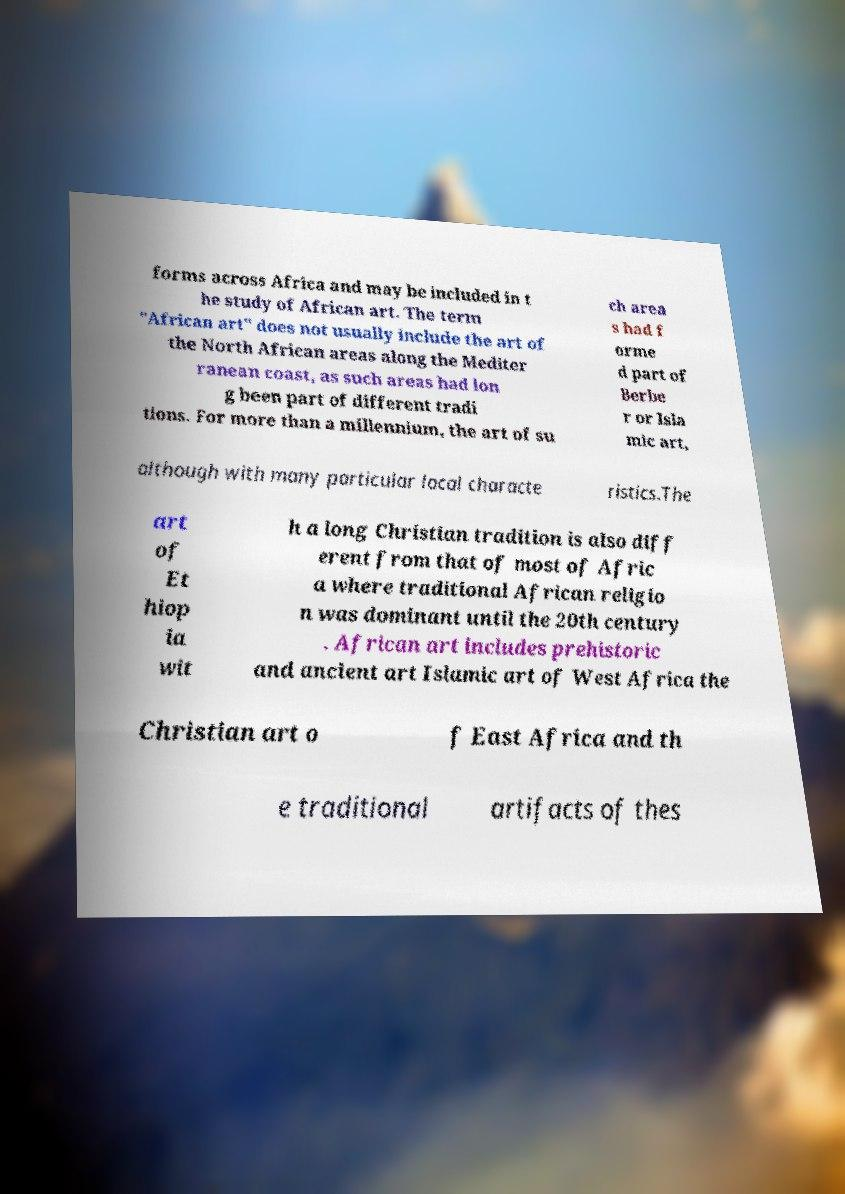Can you read and provide the text displayed in the image?This photo seems to have some interesting text. Can you extract and type it out for me? forms across Africa and may be included in t he study of African art. The term "African art" does not usually include the art of the North African areas along the Mediter ranean coast, as such areas had lon g been part of different tradi tions. For more than a millennium, the art of su ch area s had f orme d part of Berbe r or Isla mic art, although with many particular local characte ristics.The art of Et hiop ia wit h a long Christian tradition is also diff erent from that of most of Afric a where traditional African religio n was dominant until the 20th century . African art includes prehistoric and ancient art Islamic art of West Africa the Christian art o f East Africa and th e traditional artifacts of thes 